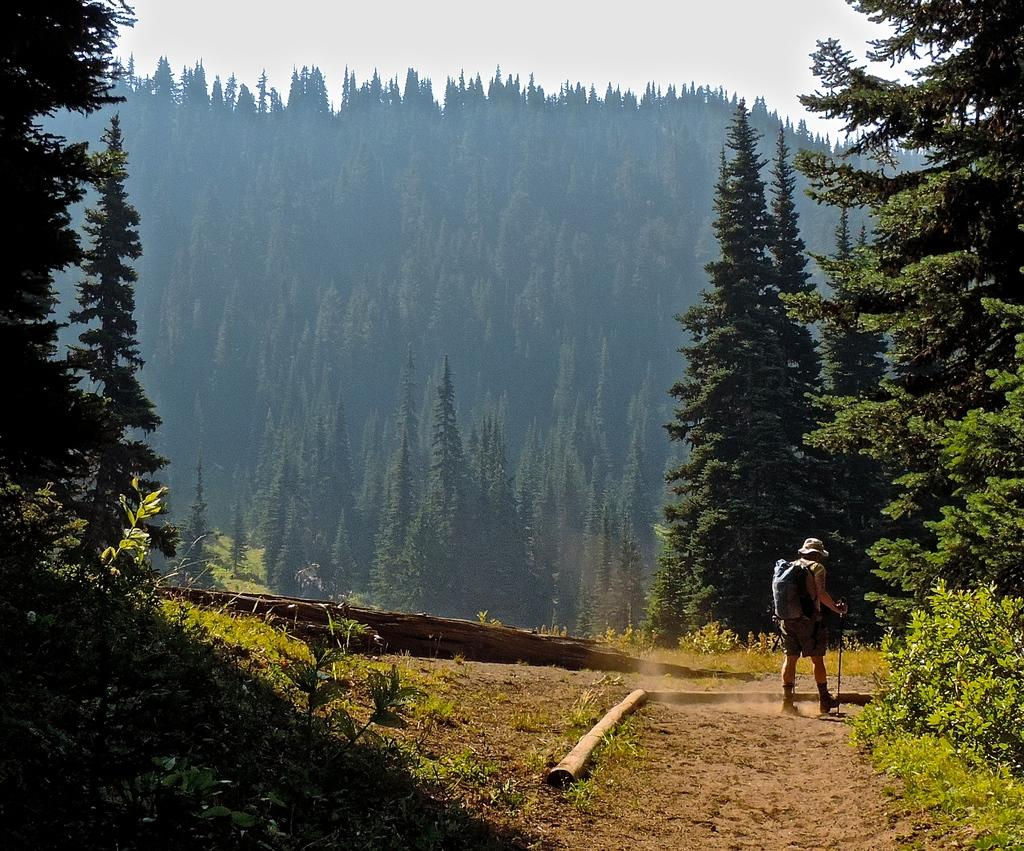What type of landscape is depicted in the image? The image features hills and trees. What objects can be seen on the ground in the image? There are logs in the image. Who is present in the image? There is a person in the image. What accessories is the person wearing? The person is wearing a bag and a cap. What is the person holding in the image? The person is holding a stick. What is the rate of inflation in the society depicted in the image? There is no society depicted in the image, as it features a person holding a stick in a natural setting. 